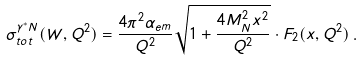<formula> <loc_0><loc_0><loc_500><loc_500>\sigma _ { t o t } ^ { \gamma ^ { * } N } ( W , Q ^ { 2 } ) = \frac { 4 \pi ^ { 2 } \alpha _ { e m } } { Q ^ { 2 } } \sqrt { 1 + \frac { 4 M _ { N } ^ { 2 } x ^ { 2 } } { Q ^ { 2 } } } \cdot F _ { 2 } ( x , Q ^ { 2 } ) \, .</formula> 